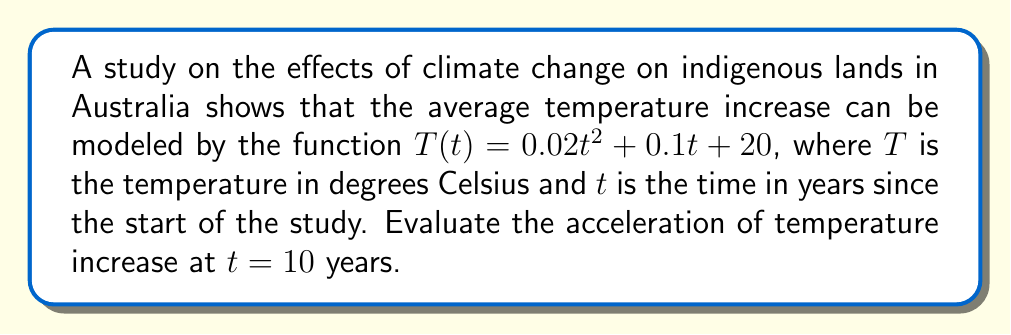Solve this math problem. To find the acceleration of temperature increase, we need to find the second derivative of the temperature function $T(t)$.

Step 1: Find the first derivative (velocity of temperature change)
$$\frac{dT}{dt} = T'(t) = 0.04t + 0.1$$

Step 2: Find the second derivative (acceleration of temperature change)
$$\frac{d^2T}{dt^2} = T''(t) = 0.04$$

Step 3: Evaluate the acceleration at $t = 10$ years
Since the second derivative is constant, the acceleration is the same at all times, including $t = 10$ years.

$$T''(10) = 0.04$$

The acceleration of temperature increase is 0.04°C/year².
Answer: $0.04$ °C/year² 